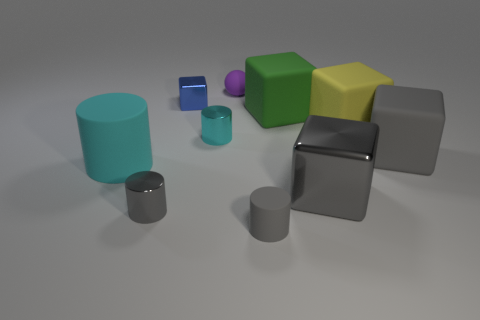Subtract all big cyan cylinders. How many cylinders are left? 3 Subtract all yellow blocks. How many blocks are left? 4 Subtract all cylinders. How many objects are left? 6 Subtract all brown cubes. Subtract all brown spheres. How many cubes are left? 5 Subtract all gray blocks. How many green cylinders are left? 0 Subtract all green matte blocks. Subtract all large cyan objects. How many objects are left? 8 Add 2 big yellow matte blocks. How many big yellow matte blocks are left? 3 Add 8 metallic cylinders. How many metallic cylinders exist? 10 Subtract 0 cyan spheres. How many objects are left? 10 